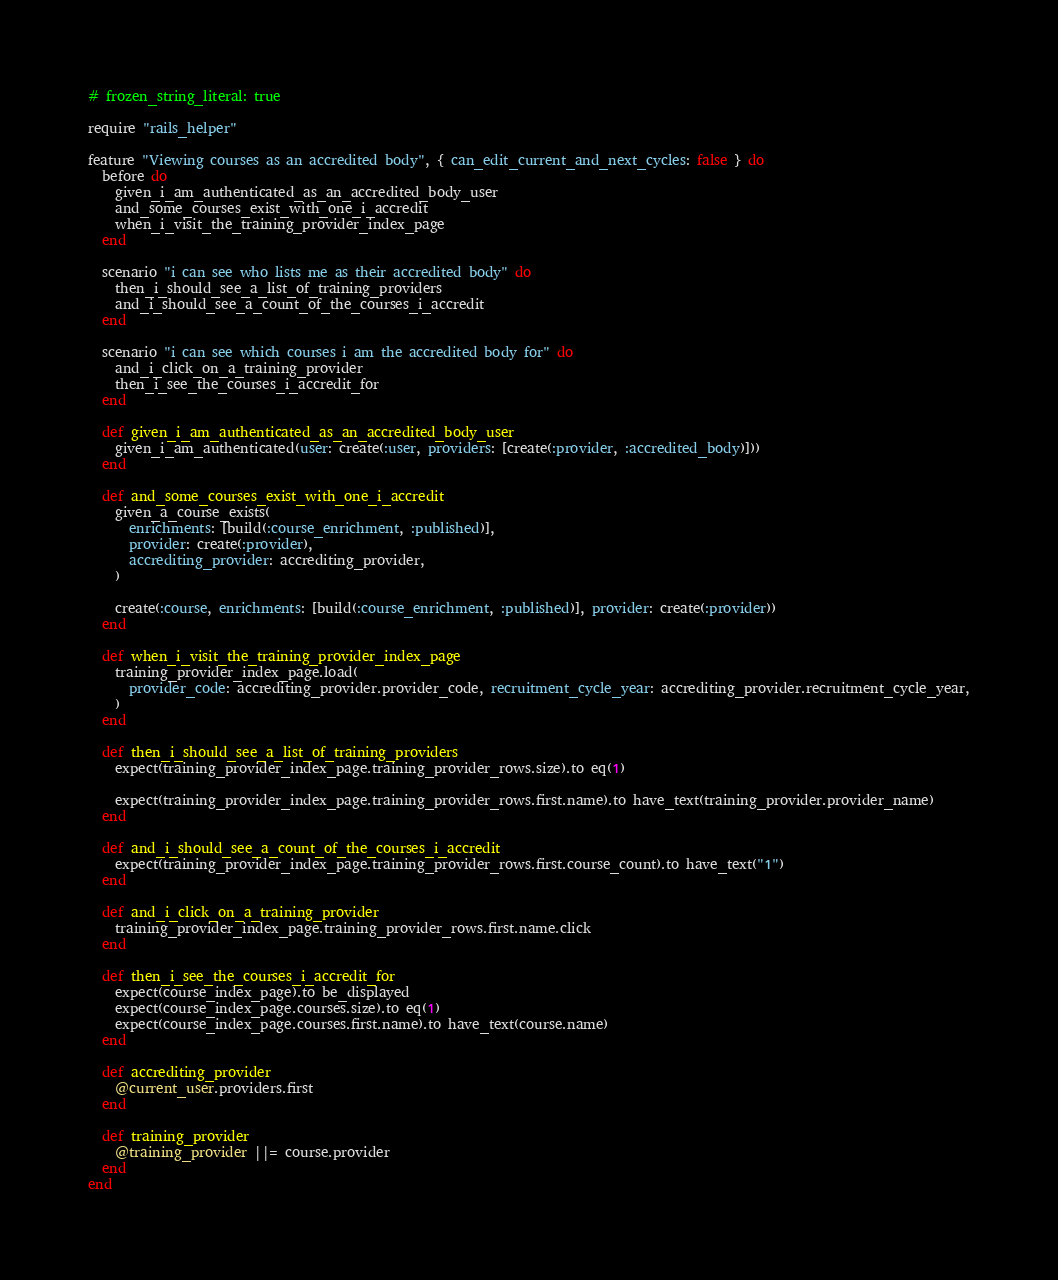Convert code to text. <code><loc_0><loc_0><loc_500><loc_500><_Ruby_># frozen_string_literal: true

require "rails_helper"

feature "Viewing courses as an accredited body", { can_edit_current_and_next_cycles: false } do
  before do
    given_i_am_authenticated_as_an_accredited_body_user
    and_some_courses_exist_with_one_i_accredit
    when_i_visit_the_training_provider_index_page
  end

  scenario "i can see who lists me as their accredited body" do
    then_i_should_see_a_list_of_training_providers
    and_i_should_see_a_count_of_the_courses_i_accredit
  end

  scenario "i can see which courses i am the accredited body for" do
    and_i_click_on_a_training_provider
    then_i_see_the_courses_i_accredit_for
  end

  def given_i_am_authenticated_as_an_accredited_body_user
    given_i_am_authenticated(user: create(:user, providers: [create(:provider, :accredited_body)]))
  end

  def and_some_courses_exist_with_one_i_accredit
    given_a_course_exists(
      enrichments: [build(:course_enrichment, :published)],
      provider: create(:provider),
      accrediting_provider: accrediting_provider,
    )

    create(:course, enrichments: [build(:course_enrichment, :published)], provider: create(:provider))
  end

  def when_i_visit_the_training_provider_index_page
    training_provider_index_page.load(
      provider_code: accrediting_provider.provider_code, recruitment_cycle_year: accrediting_provider.recruitment_cycle_year,
    )
  end

  def then_i_should_see_a_list_of_training_providers
    expect(training_provider_index_page.training_provider_rows.size).to eq(1)

    expect(training_provider_index_page.training_provider_rows.first.name).to have_text(training_provider.provider_name)
  end

  def and_i_should_see_a_count_of_the_courses_i_accredit
    expect(training_provider_index_page.training_provider_rows.first.course_count).to have_text("1")
  end

  def and_i_click_on_a_training_provider
    training_provider_index_page.training_provider_rows.first.name.click
  end

  def then_i_see_the_courses_i_accredit_for
    expect(course_index_page).to be_displayed
    expect(course_index_page.courses.size).to eq(1)
    expect(course_index_page.courses.first.name).to have_text(course.name)
  end

  def accrediting_provider
    @current_user.providers.first
  end

  def training_provider
    @training_provider ||= course.provider
  end
end
</code> 